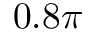Convert formula to latex. <formula><loc_0><loc_0><loc_500><loc_500>0 . 8 \pi</formula> 